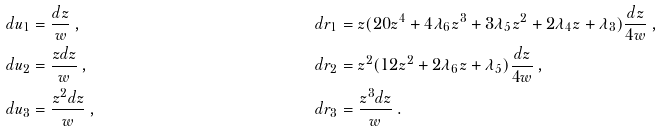Convert formula to latex. <formula><loc_0><loc_0><loc_500><loc_500>d u _ { 1 } & = \frac { d z } { w } \, , & \quad d r _ { 1 } & = z ( 2 0 z ^ { 4 } + 4 \lambda _ { 6 } z ^ { 3 } + 3 \lambda _ { 5 } z ^ { 2 } + 2 \lambda _ { 4 } z + \lambda _ { 3 } ) \frac { d z } { 4 w } \, , \\ d u _ { 2 } & = \frac { z d z } { w } \, , & \quad d r _ { 2 } & = z ^ { 2 } ( 1 2 z ^ { 2 } + 2 \lambda _ { 6 } z + \lambda _ { 5 } ) \frac { d z } { 4 w } \, , \\ d u _ { 3 } & = \frac { z ^ { 2 } d z } { w } \, , & \quad d r _ { 3 } & = \frac { z ^ { 3 } d z } { w } \, .</formula> 